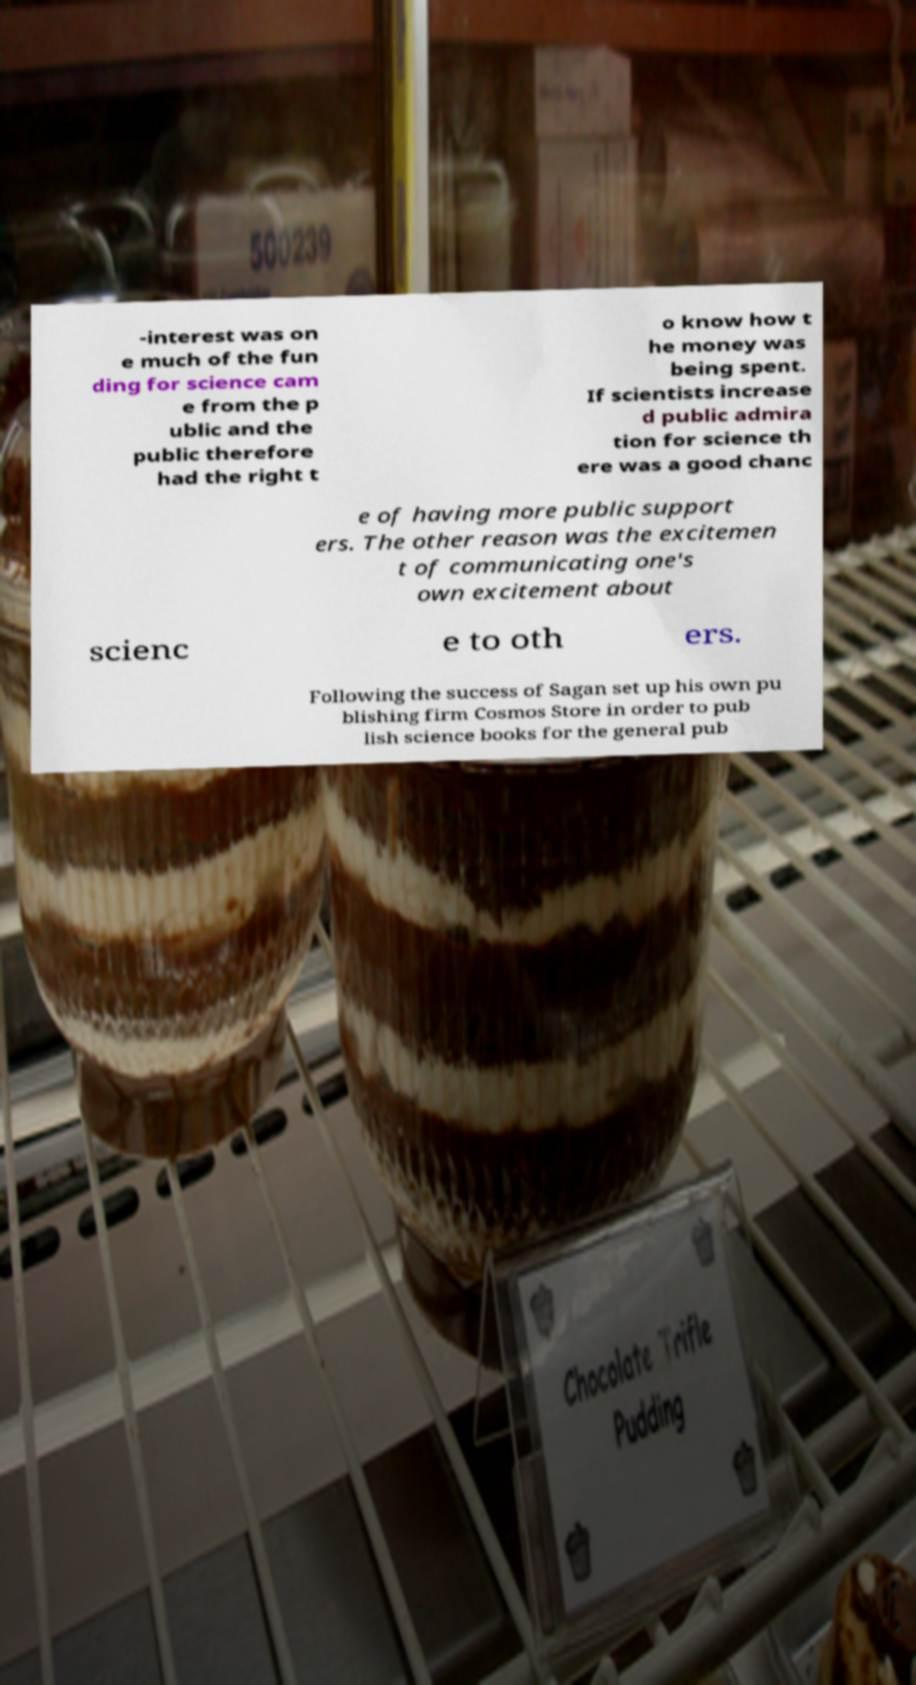Can you read and provide the text displayed in the image?This photo seems to have some interesting text. Can you extract and type it out for me? -interest was on e much of the fun ding for science cam e from the p ublic and the public therefore had the right t o know how t he money was being spent. If scientists increase d public admira tion for science th ere was a good chanc e of having more public support ers. The other reason was the excitemen t of communicating one's own excitement about scienc e to oth ers. Following the success of Sagan set up his own pu blishing firm Cosmos Store in order to pub lish science books for the general pub 